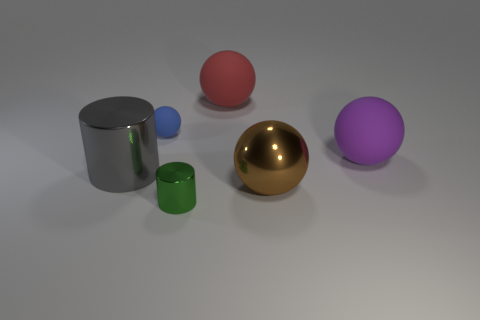Subtract all rubber spheres. How many spheres are left? 1 Subtract all yellow spheres. Subtract all gray blocks. How many spheres are left? 4 Add 4 gray cylinders. How many objects exist? 10 Subtract all balls. How many objects are left? 2 Subtract 0 yellow blocks. How many objects are left? 6 Subtract all red matte spheres. Subtract all tiny green metal things. How many objects are left? 4 Add 4 red objects. How many red objects are left? 5 Add 2 large red spheres. How many large red spheres exist? 3 